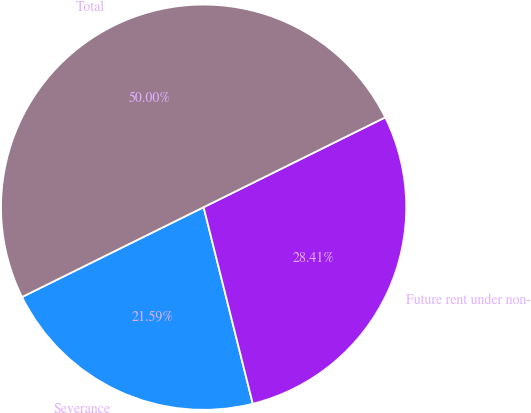Convert chart. <chart><loc_0><loc_0><loc_500><loc_500><pie_chart><fcel>Severance<fcel>Future rent under non-<fcel>Total<nl><fcel>21.59%<fcel>28.41%<fcel>50.0%<nl></chart> 